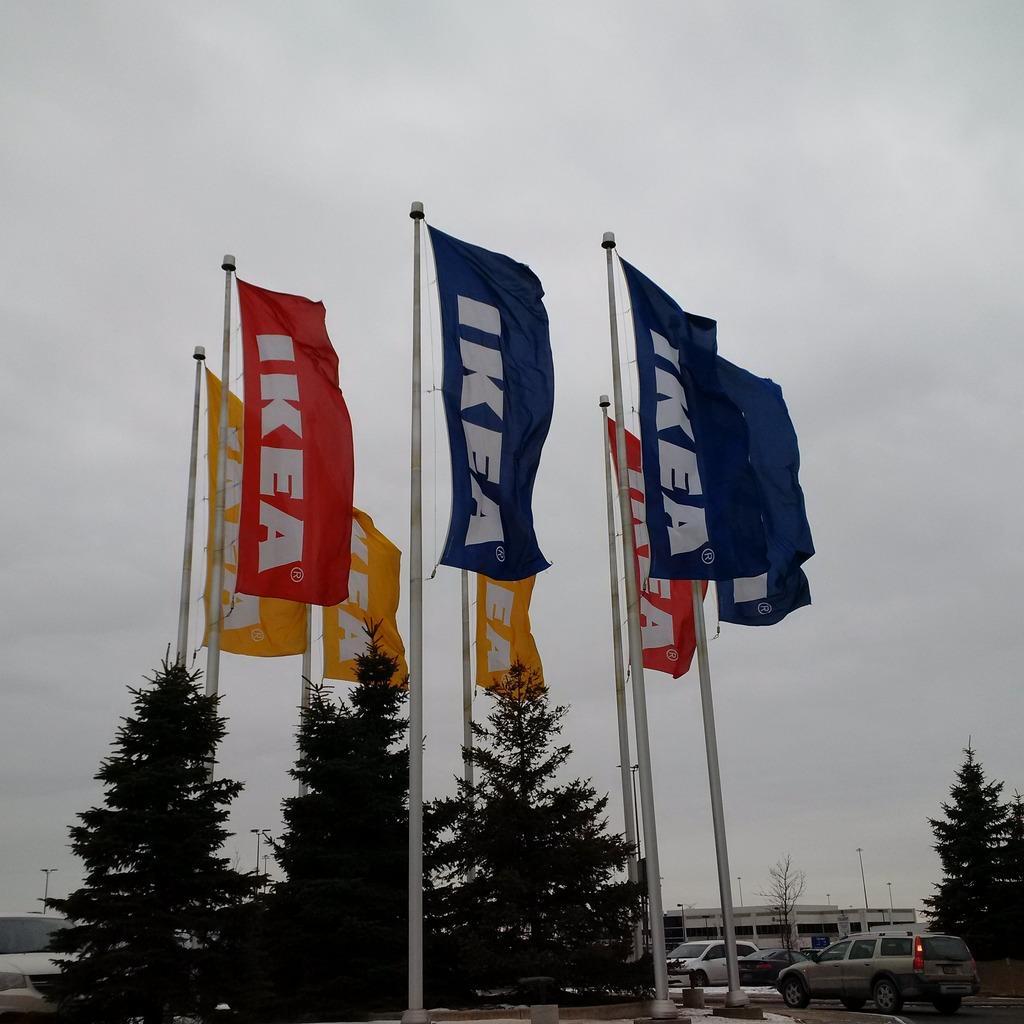Could you give a brief overview of what you see in this image? In this image I can see few white colored poles and flags attached to them, few trees, few cars on the road and in the background I can see a building and the sky. 